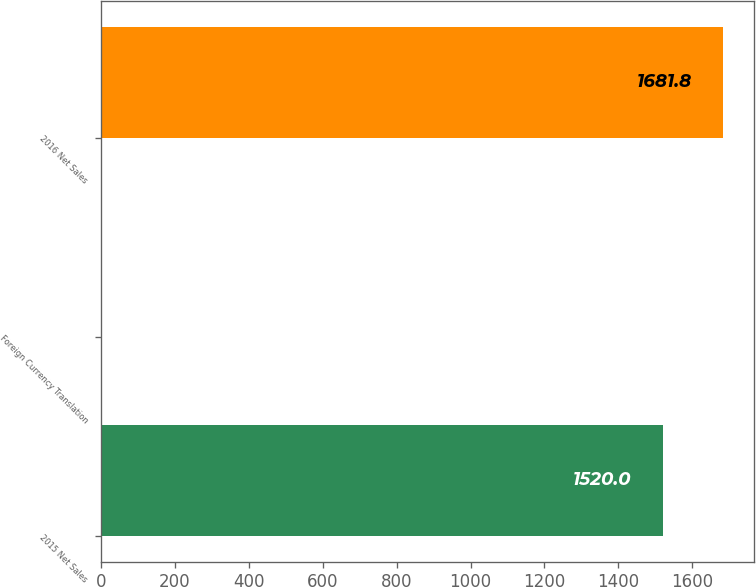<chart> <loc_0><loc_0><loc_500><loc_500><bar_chart><fcel>2015 Net Sales<fcel>Foreign Currency Translation<fcel>2016 Net Sales<nl><fcel>1520<fcel>2<fcel>1681.8<nl></chart> 